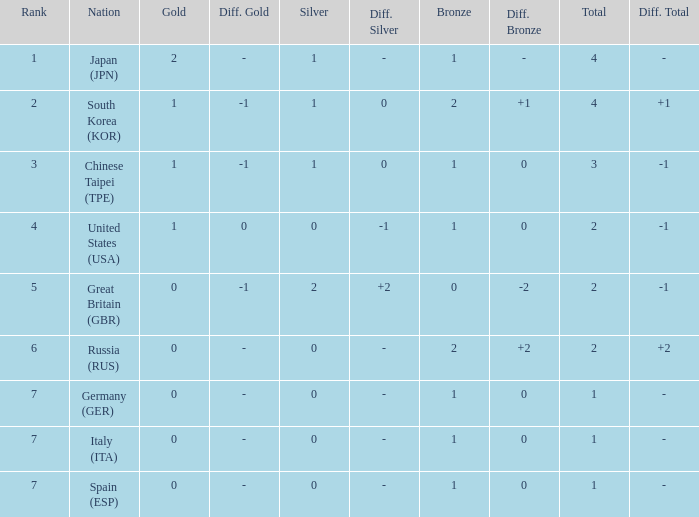What is the rank of the country with more than 2 medals, and 2 gold medals? 1.0. 